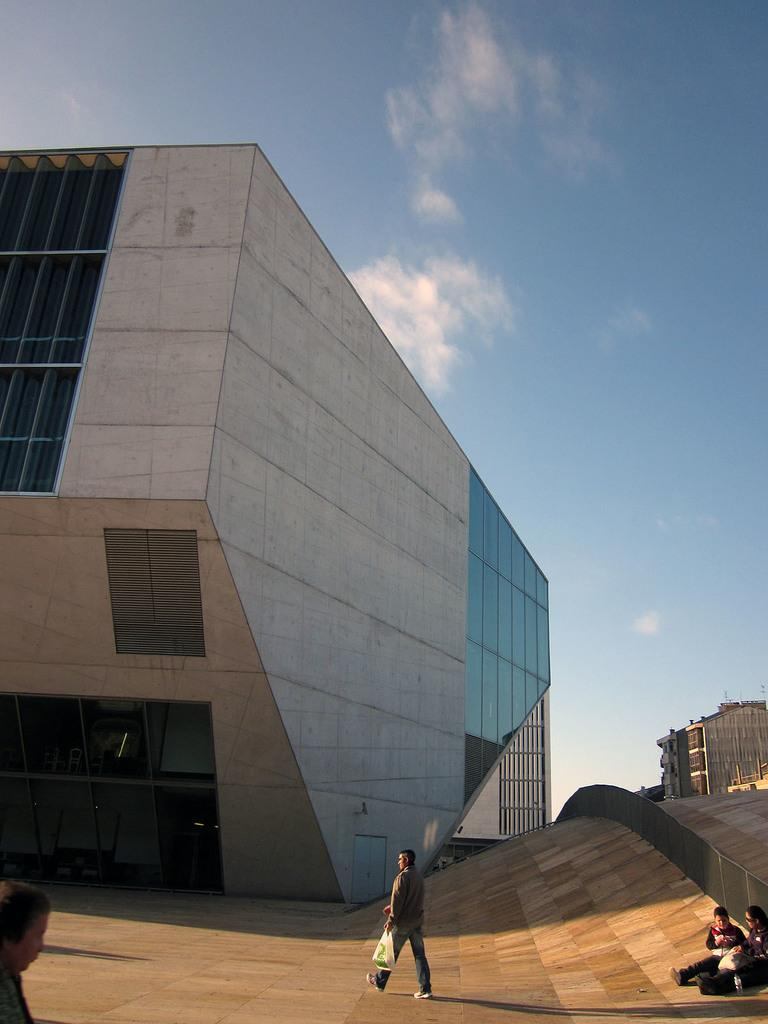What is the person in the image doing? The person in the image is walking on the floor. Are there any other people in the image? Yes, there are persons sitting on the floor in the image. What can be seen in the background of the image? Buildings and the sky are visible in the image. What is the condition of the sky in the image? The sky is visible with clouds present in the image. What type of work is the person doing at home in the image? There is no indication of work or a home in the image; it simply shows a person walking and others sitting on the floor. 